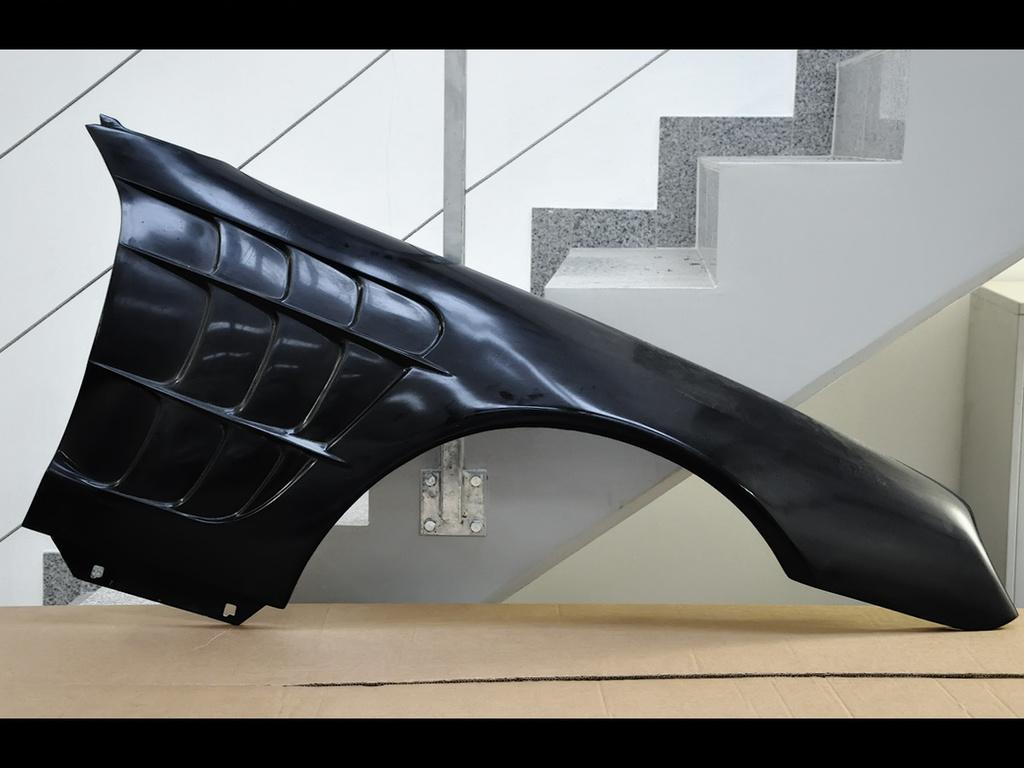What is the main object in the image? There is a cardboard box in the image. Is there anything on top of the cardboard box? Yes, there is an object on the cardboard box. What can be seen in the background of the image? There are steps and a wall visible in the background of the image. How many cats are using the cardboard box as bait in the image? There are no cats or bait present in the image. 